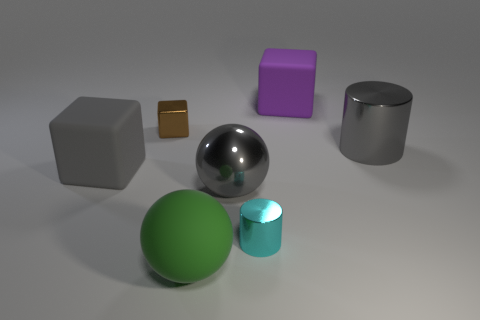Is the material of the purple block the same as the cylinder left of the big gray cylinder?
Your answer should be compact. No. What material is the small thing behind the large cube to the left of the green ball made of?
Offer a terse response. Metal. Are there more rubber objects in front of the tiny metal cube than big purple cubes?
Ensure brevity in your answer.  Yes. Are any tiny brown shiny things visible?
Offer a very short reply. Yes. There is a big rubber block in front of the small brown block; what is its color?
Your answer should be compact. Gray. What is the material of the gray block that is the same size as the purple matte object?
Your response must be concise. Rubber. What number of other objects are the same material as the large purple object?
Give a very brief answer. 2. What color is the large matte thing that is in front of the big purple object and behind the cyan cylinder?
Make the answer very short. Gray. What number of objects are big rubber things on the left side of the large green matte sphere or big purple objects?
Offer a terse response. 2. How many other things are the same color as the big shiny cylinder?
Offer a very short reply. 2. 